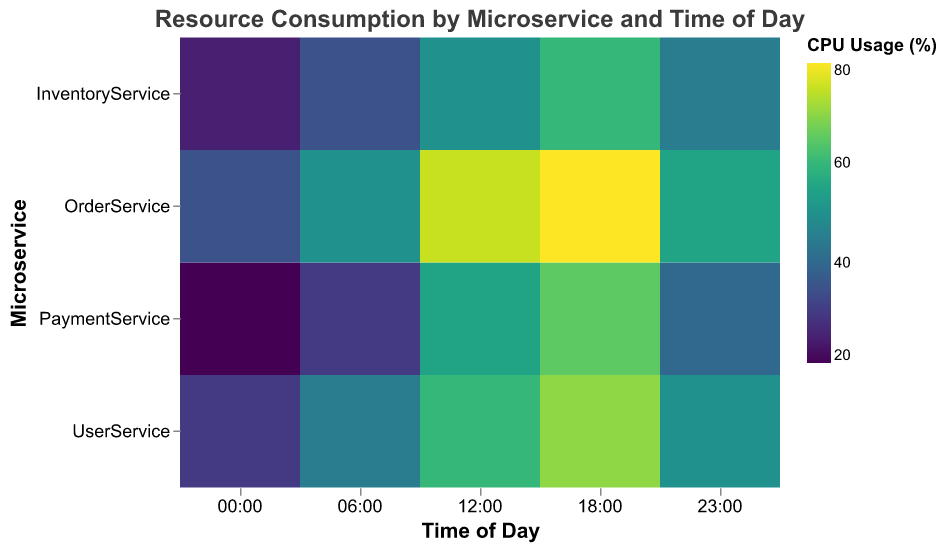Which microservice has the highest CPU usage overall? By looking at the color intensity across the heatmap, OrderService shows the highest CPU usage in the 18:00 time slot with 80%.
Answer: OrderService At what time does UserService have its highest memory usage? For UserService, check the memory usage in the tooltip across different times, the highest memory usage is at 18:00 with 220 MB.
Answer: 18:00 How does the CPU usage of PaymentService at 12:00 compare to InventoryService at the same time? At 12:00, PaymentService has a CPU usage of 55%, while InventoryService has a CPU usage of 50%. PaymentService's CPU usage is higher.
Answer: PaymentService has higher CPU usage at 12:00 Which microservice demonstrates the largest change in CPU usage across different times of the day? Calculate the range (max - min) of CPU usage for each microservice: UserService (70 - 30 = 40%), PaymentService (65 - 20 = 45%), InventoryService (60 - 25 = 35%), and OrderService (80 - 35 = 45%). Both PaymentService and OrderService show the largest change.
Answer: PaymentService and OrderService What is the average CPU usage of UserService throughout the day? UserService's CPU usages are 30, 45, 60, 70, and 50. Sum these values (30 + 45 + 60 + 70 + 50 = 255) and divide by 5 to get the average (255/5 = 51%).
Answer: 51% How does the memory usage pattern of OrderService compare to that of PaymentService? Observing the heatmap, OrderService consistently uses more memory than PaymentService at any given time of the day. The highest for OrderService is 240 MB and for PaymentService 210 MB.
Answer: OrderService uses more memory at all times 